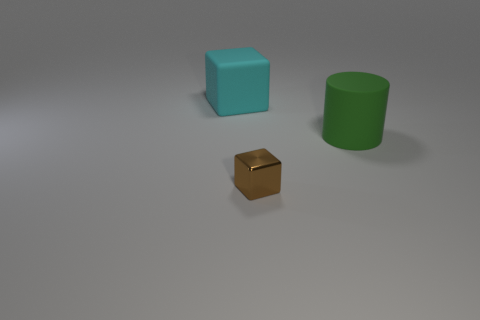Add 1 brown things. How many objects exist? 4 Subtract all cylinders. How many objects are left? 2 Subtract all big brown matte objects. Subtract all green objects. How many objects are left? 2 Add 1 large green matte cylinders. How many large green matte cylinders are left? 2 Add 2 rubber cylinders. How many rubber cylinders exist? 3 Subtract 1 cyan blocks. How many objects are left? 2 